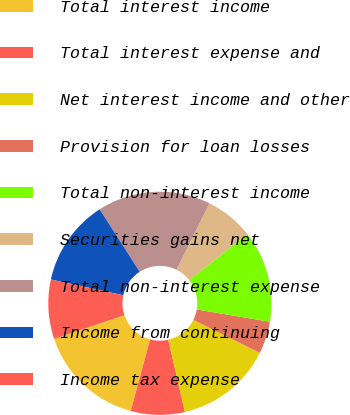Convert chart to OTSL. <chart><loc_0><loc_0><loc_500><loc_500><pie_chart><fcel>Total interest income<fcel>Total interest expense and<fcel>Net interest income and other<fcel>Provision for loan losses<fcel>Total non-interest income<fcel>Securities gains net<fcel>Total non-interest expense<fcel>Income from continuing<fcel>Income tax expense<nl><fcel>15.62%<fcel>7.81%<fcel>14.06%<fcel>4.69%<fcel>13.28%<fcel>7.03%<fcel>16.41%<fcel>12.5%<fcel>8.59%<nl></chart> 